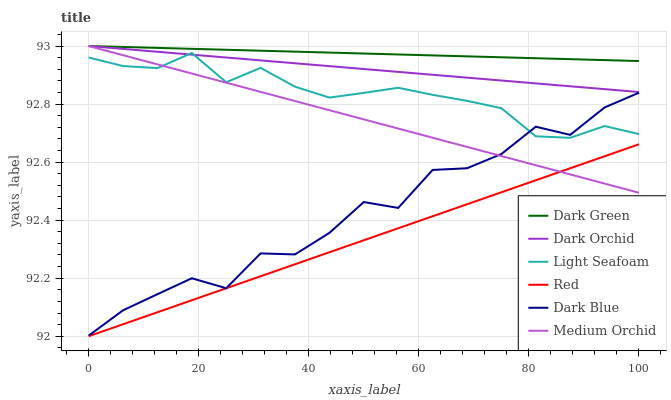Does Dark Orchid have the minimum area under the curve?
Answer yes or no. No. Does Dark Orchid have the maximum area under the curve?
Answer yes or no. No. Is Dark Blue the smoothest?
Answer yes or no. No. Is Dark Orchid the roughest?
Answer yes or no. No. Does Dark Orchid have the lowest value?
Answer yes or no. No. Does Dark Blue have the highest value?
Answer yes or no. No. Is Red less than Dark Orchid?
Answer yes or no. Yes. Is Dark Green greater than Red?
Answer yes or no. Yes. Does Red intersect Dark Orchid?
Answer yes or no. No. 